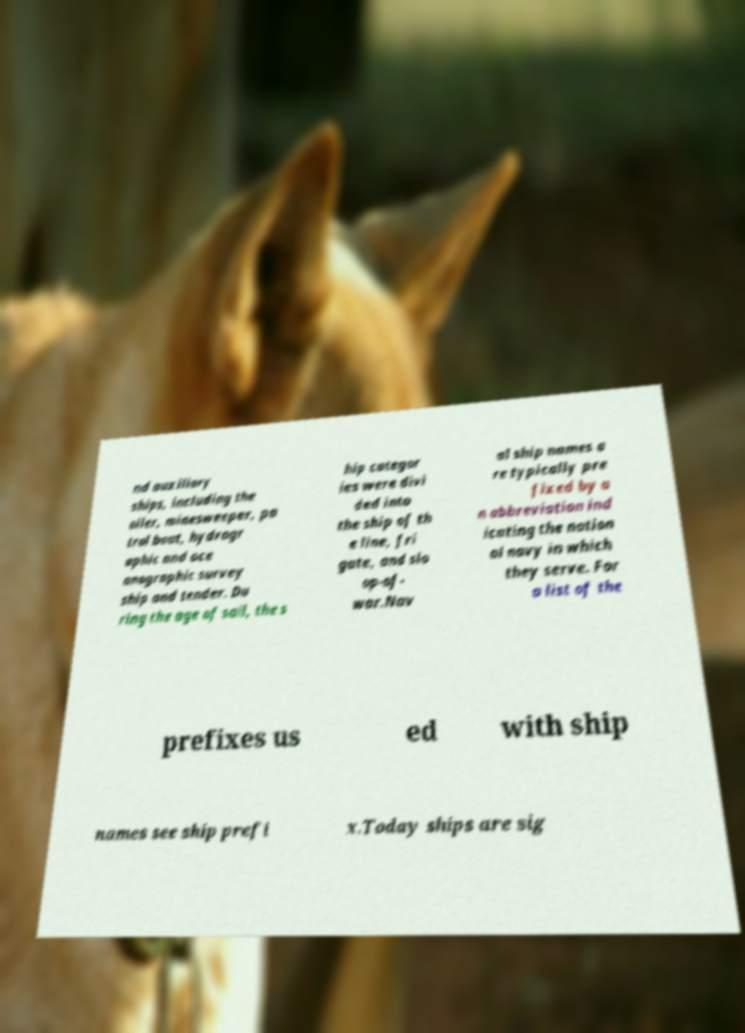I need the written content from this picture converted into text. Can you do that? nd auxiliary ships, including the oiler, minesweeper, pa trol boat, hydrogr aphic and oce anographic survey ship and tender. Du ring the age of sail, the s hip categor ies were divi ded into the ship of th e line, fri gate, and slo op-of- war.Nav al ship names a re typically pre fixed by a n abbreviation ind icating the nation al navy in which they serve. For a list of the prefixes us ed with ship names see ship prefi x.Today ships are sig 